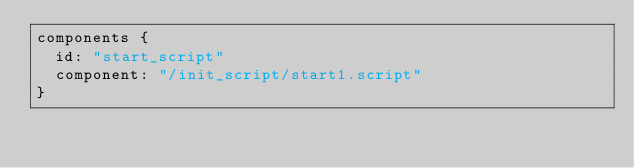<code> <loc_0><loc_0><loc_500><loc_500><_Go_>components {
  id: "start_script"
  component: "/init_script/start1.script"
}
</code> 